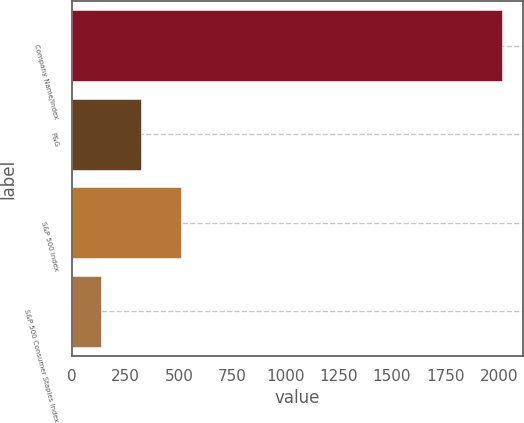Convert chart. <chart><loc_0><loc_0><loc_500><loc_500><bar_chart><fcel>Company Name/Index<fcel>P&G<fcel>S&P 500 Index<fcel>S&P 500 Consumer Staples Index<nl><fcel>2014<fcel>322.9<fcel>510.8<fcel>135<nl></chart> 